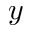<formula> <loc_0><loc_0><loc_500><loc_500>y</formula> 